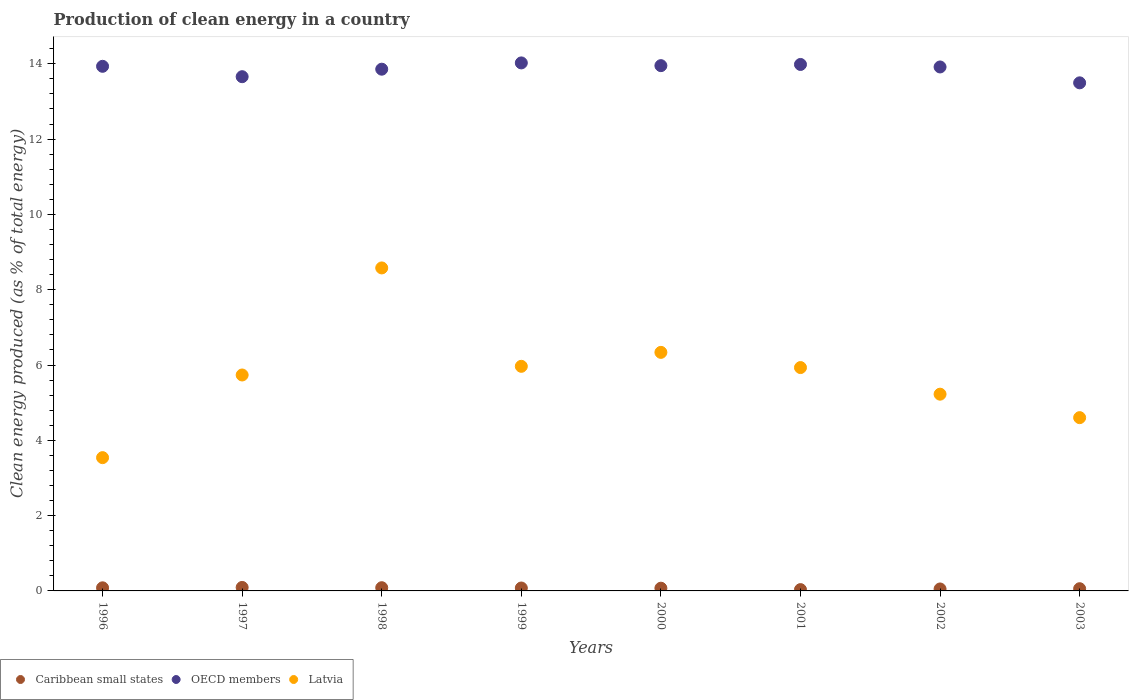Is the number of dotlines equal to the number of legend labels?
Ensure brevity in your answer.  Yes. What is the percentage of clean energy produced in Latvia in 1996?
Offer a terse response. 3.54. Across all years, what is the maximum percentage of clean energy produced in Caribbean small states?
Your answer should be very brief. 0.09. Across all years, what is the minimum percentage of clean energy produced in Latvia?
Your response must be concise. 3.54. What is the total percentage of clean energy produced in Caribbean small states in the graph?
Your answer should be compact. 0.56. What is the difference between the percentage of clean energy produced in OECD members in 2000 and that in 2003?
Ensure brevity in your answer.  0.46. What is the difference between the percentage of clean energy produced in Caribbean small states in 2000 and the percentage of clean energy produced in Latvia in 1996?
Keep it short and to the point. -3.47. What is the average percentage of clean energy produced in Latvia per year?
Make the answer very short. 5.74. In the year 1997, what is the difference between the percentage of clean energy produced in OECD members and percentage of clean energy produced in Caribbean small states?
Your answer should be very brief. 13.57. What is the ratio of the percentage of clean energy produced in OECD members in 2002 to that in 2003?
Offer a very short reply. 1.03. Is the percentage of clean energy produced in Latvia in 1997 less than that in 1998?
Give a very brief answer. Yes. What is the difference between the highest and the second highest percentage of clean energy produced in Caribbean small states?
Your answer should be very brief. 0.01. What is the difference between the highest and the lowest percentage of clean energy produced in Latvia?
Give a very brief answer. 5.04. Is the sum of the percentage of clean energy produced in OECD members in 1999 and 2001 greater than the maximum percentage of clean energy produced in Caribbean small states across all years?
Offer a terse response. Yes. Is it the case that in every year, the sum of the percentage of clean energy produced in OECD members and percentage of clean energy produced in Latvia  is greater than the percentage of clean energy produced in Caribbean small states?
Offer a terse response. Yes. Is the percentage of clean energy produced in Latvia strictly greater than the percentage of clean energy produced in OECD members over the years?
Make the answer very short. No. How many dotlines are there?
Offer a terse response. 3. Does the graph contain any zero values?
Keep it short and to the point. No. Does the graph contain grids?
Give a very brief answer. No. Where does the legend appear in the graph?
Your response must be concise. Bottom left. How many legend labels are there?
Offer a terse response. 3. How are the legend labels stacked?
Give a very brief answer. Horizontal. What is the title of the graph?
Give a very brief answer. Production of clean energy in a country. Does "Rwanda" appear as one of the legend labels in the graph?
Your answer should be very brief. No. What is the label or title of the Y-axis?
Ensure brevity in your answer.  Clean energy produced (as % of total energy). What is the Clean energy produced (as % of total energy) in Caribbean small states in 1996?
Ensure brevity in your answer.  0.08. What is the Clean energy produced (as % of total energy) of OECD members in 1996?
Your answer should be very brief. 13.93. What is the Clean energy produced (as % of total energy) in Latvia in 1996?
Provide a succinct answer. 3.54. What is the Clean energy produced (as % of total energy) of Caribbean small states in 1997?
Your answer should be very brief. 0.09. What is the Clean energy produced (as % of total energy) in OECD members in 1997?
Provide a short and direct response. 13.66. What is the Clean energy produced (as % of total energy) of Latvia in 1997?
Provide a succinct answer. 5.74. What is the Clean energy produced (as % of total energy) in Caribbean small states in 1998?
Ensure brevity in your answer.  0.09. What is the Clean energy produced (as % of total energy) of OECD members in 1998?
Your response must be concise. 13.86. What is the Clean energy produced (as % of total energy) in Latvia in 1998?
Your answer should be compact. 8.58. What is the Clean energy produced (as % of total energy) of Caribbean small states in 1999?
Make the answer very short. 0.08. What is the Clean energy produced (as % of total energy) of OECD members in 1999?
Your response must be concise. 14.02. What is the Clean energy produced (as % of total energy) of Latvia in 1999?
Ensure brevity in your answer.  5.97. What is the Clean energy produced (as % of total energy) of Caribbean small states in 2000?
Your answer should be compact. 0.07. What is the Clean energy produced (as % of total energy) of OECD members in 2000?
Provide a short and direct response. 13.95. What is the Clean energy produced (as % of total energy) in Latvia in 2000?
Make the answer very short. 6.34. What is the Clean energy produced (as % of total energy) in Caribbean small states in 2001?
Your answer should be compact. 0.03. What is the Clean energy produced (as % of total energy) in OECD members in 2001?
Offer a very short reply. 13.98. What is the Clean energy produced (as % of total energy) in Latvia in 2001?
Make the answer very short. 5.93. What is the Clean energy produced (as % of total energy) in Caribbean small states in 2002?
Provide a succinct answer. 0.05. What is the Clean energy produced (as % of total energy) in OECD members in 2002?
Offer a very short reply. 13.92. What is the Clean energy produced (as % of total energy) of Latvia in 2002?
Offer a very short reply. 5.23. What is the Clean energy produced (as % of total energy) of Caribbean small states in 2003?
Offer a terse response. 0.06. What is the Clean energy produced (as % of total energy) in OECD members in 2003?
Provide a short and direct response. 13.49. What is the Clean energy produced (as % of total energy) in Latvia in 2003?
Your response must be concise. 4.6. Across all years, what is the maximum Clean energy produced (as % of total energy) in Caribbean small states?
Your response must be concise. 0.09. Across all years, what is the maximum Clean energy produced (as % of total energy) of OECD members?
Ensure brevity in your answer.  14.02. Across all years, what is the maximum Clean energy produced (as % of total energy) of Latvia?
Your response must be concise. 8.58. Across all years, what is the minimum Clean energy produced (as % of total energy) of Caribbean small states?
Your response must be concise. 0.03. Across all years, what is the minimum Clean energy produced (as % of total energy) of OECD members?
Keep it short and to the point. 13.49. Across all years, what is the minimum Clean energy produced (as % of total energy) of Latvia?
Your answer should be very brief. 3.54. What is the total Clean energy produced (as % of total energy) in Caribbean small states in the graph?
Your answer should be very brief. 0.56. What is the total Clean energy produced (as % of total energy) in OECD members in the graph?
Your answer should be very brief. 110.82. What is the total Clean energy produced (as % of total energy) of Latvia in the graph?
Keep it short and to the point. 45.91. What is the difference between the Clean energy produced (as % of total energy) in Caribbean small states in 1996 and that in 1997?
Ensure brevity in your answer.  -0.01. What is the difference between the Clean energy produced (as % of total energy) in OECD members in 1996 and that in 1997?
Your response must be concise. 0.28. What is the difference between the Clean energy produced (as % of total energy) of Latvia in 1996 and that in 1997?
Provide a short and direct response. -2.2. What is the difference between the Clean energy produced (as % of total energy) of Caribbean small states in 1996 and that in 1998?
Make the answer very short. -0. What is the difference between the Clean energy produced (as % of total energy) of OECD members in 1996 and that in 1998?
Provide a succinct answer. 0.08. What is the difference between the Clean energy produced (as % of total energy) of Latvia in 1996 and that in 1998?
Give a very brief answer. -5.04. What is the difference between the Clean energy produced (as % of total energy) of Caribbean small states in 1996 and that in 1999?
Give a very brief answer. 0.01. What is the difference between the Clean energy produced (as % of total energy) of OECD members in 1996 and that in 1999?
Offer a terse response. -0.09. What is the difference between the Clean energy produced (as % of total energy) of Latvia in 1996 and that in 1999?
Your response must be concise. -2.43. What is the difference between the Clean energy produced (as % of total energy) of Caribbean small states in 1996 and that in 2000?
Give a very brief answer. 0.01. What is the difference between the Clean energy produced (as % of total energy) of OECD members in 1996 and that in 2000?
Ensure brevity in your answer.  -0.02. What is the difference between the Clean energy produced (as % of total energy) in Latvia in 1996 and that in 2000?
Offer a very short reply. -2.8. What is the difference between the Clean energy produced (as % of total energy) of Caribbean small states in 1996 and that in 2001?
Keep it short and to the point. 0.05. What is the difference between the Clean energy produced (as % of total energy) in OECD members in 1996 and that in 2001?
Offer a very short reply. -0.05. What is the difference between the Clean energy produced (as % of total energy) in Latvia in 1996 and that in 2001?
Ensure brevity in your answer.  -2.39. What is the difference between the Clean energy produced (as % of total energy) in Caribbean small states in 1996 and that in 2002?
Ensure brevity in your answer.  0.03. What is the difference between the Clean energy produced (as % of total energy) of OECD members in 1996 and that in 2002?
Keep it short and to the point. 0.02. What is the difference between the Clean energy produced (as % of total energy) of Latvia in 1996 and that in 2002?
Offer a terse response. -1.69. What is the difference between the Clean energy produced (as % of total energy) of Caribbean small states in 1996 and that in 2003?
Provide a short and direct response. 0.02. What is the difference between the Clean energy produced (as % of total energy) of OECD members in 1996 and that in 2003?
Provide a succinct answer. 0.44. What is the difference between the Clean energy produced (as % of total energy) of Latvia in 1996 and that in 2003?
Offer a very short reply. -1.06. What is the difference between the Clean energy produced (as % of total energy) of Caribbean small states in 1997 and that in 1998?
Give a very brief answer. 0.01. What is the difference between the Clean energy produced (as % of total energy) of OECD members in 1997 and that in 1998?
Ensure brevity in your answer.  -0.2. What is the difference between the Clean energy produced (as % of total energy) in Latvia in 1997 and that in 1998?
Your answer should be very brief. -2.84. What is the difference between the Clean energy produced (as % of total energy) in Caribbean small states in 1997 and that in 1999?
Your response must be concise. 0.02. What is the difference between the Clean energy produced (as % of total energy) in OECD members in 1997 and that in 1999?
Ensure brevity in your answer.  -0.37. What is the difference between the Clean energy produced (as % of total energy) in Latvia in 1997 and that in 1999?
Your answer should be very brief. -0.23. What is the difference between the Clean energy produced (as % of total energy) of Caribbean small states in 1997 and that in 2000?
Keep it short and to the point. 0.02. What is the difference between the Clean energy produced (as % of total energy) of OECD members in 1997 and that in 2000?
Offer a very short reply. -0.29. What is the difference between the Clean energy produced (as % of total energy) in Latvia in 1997 and that in 2000?
Your response must be concise. -0.6. What is the difference between the Clean energy produced (as % of total energy) of Caribbean small states in 1997 and that in 2001?
Your answer should be compact. 0.06. What is the difference between the Clean energy produced (as % of total energy) of OECD members in 1997 and that in 2001?
Your answer should be compact. -0.32. What is the difference between the Clean energy produced (as % of total energy) of Latvia in 1997 and that in 2001?
Provide a short and direct response. -0.2. What is the difference between the Clean energy produced (as % of total energy) in Caribbean small states in 1997 and that in 2002?
Give a very brief answer. 0.04. What is the difference between the Clean energy produced (as % of total energy) in OECD members in 1997 and that in 2002?
Your answer should be compact. -0.26. What is the difference between the Clean energy produced (as % of total energy) of Latvia in 1997 and that in 2002?
Offer a terse response. 0.51. What is the difference between the Clean energy produced (as % of total energy) of Caribbean small states in 1997 and that in 2003?
Offer a very short reply. 0.03. What is the difference between the Clean energy produced (as % of total energy) of OECD members in 1997 and that in 2003?
Provide a succinct answer. 0.16. What is the difference between the Clean energy produced (as % of total energy) in Latvia in 1997 and that in 2003?
Offer a terse response. 1.13. What is the difference between the Clean energy produced (as % of total energy) of Caribbean small states in 1998 and that in 1999?
Provide a short and direct response. 0.01. What is the difference between the Clean energy produced (as % of total energy) of OECD members in 1998 and that in 1999?
Make the answer very short. -0.17. What is the difference between the Clean energy produced (as % of total energy) of Latvia in 1998 and that in 1999?
Ensure brevity in your answer.  2.61. What is the difference between the Clean energy produced (as % of total energy) of Caribbean small states in 1998 and that in 2000?
Your response must be concise. 0.01. What is the difference between the Clean energy produced (as % of total energy) of OECD members in 1998 and that in 2000?
Keep it short and to the point. -0.09. What is the difference between the Clean energy produced (as % of total energy) in Latvia in 1998 and that in 2000?
Offer a terse response. 2.24. What is the difference between the Clean energy produced (as % of total energy) of Caribbean small states in 1998 and that in 2001?
Your answer should be compact. 0.05. What is the difference between the Clean energy produced (as % of total energy) in OECD members in 1998 and that in 2001?
Your answer should be compact. -0.13. What is the difference between the Clean energy produced (as % of total energy) of Latvia in 1998 and that in 2001?
Provide a succinct answer. 2.65. What is the difference between the Clean energy produced (as % of total energy) of Caribbean small states in 1998 and that in 2002?
Provide a succinct answer. 0.03. What is the difference between the Clean energy produced (as % of total energy) of OECD members in 1998 and that in 2002?
Your answer should be very brief. -0.06. What is the difference between the Clean energy produced (as % of total energy) of Latvia in 1998 and that in 2002?
Offer a very short reply. 3.35. What is the difference between the Clean energy produced (as % of total energy) of Caribbean small states in 1998 and that in 2003?
Your answer should be compact. 0.03. What is the difference between the Clean energy produced (as % of total energy) of OECD members in 1998 and that in 2003?
Offer a very short reply. 0.36. What is the difference between the Clean energy produced (as % of total energy) in Latvia in 1998 and that in 2003?
Give a very brief answer. 3.98. What is the difference between the Clean energy produced (as % of total energy) of Caribbean small states in 1999 and that in 2000?
Your answer should be very brief. 0.01. What is the difference between the Clean energy produced (as % of total energy) in OECD members in 1999 and that in 2000?
Provide a short and direct response. 0.07. What is the difference between the Clean energy produced (as % of total energy) in Latvia in 1999 and that in 2000?
Make the answer very short. -0.37. What is the difference between the Clean energy produced (as % of total energy) in Caribbean small states in 1999 and that in 2001?
Keep it short and to the point. 0.04. What is the difference between the Clean energy produced (as % of total energy) of OECD members in 1999 and that in 2001?
Your answer should be compact. 0.04. What is the difference between the Clean energy produced (as % of total energy) of Latvia in 1999 and that in 2001?
Your response must be concise. 0.03. What is the difference between the Clean energy produced (as % of total energy) of Caribbean small states in 1999 and that in 2002?
Make the answer very short. 0.03. What is the difference between the Clean energy produced (as % of total energy) of OECD members in 1999 and that in 2002?
Your answer should be very brief. 0.11. What is the difference between the Clean energy produced (as % of total energy) in Latvia in 1999 and that in 2002?
Give a very brief answer. 0.74. What is the difference between the Clean energy produced (as % of total energy) in Caribbean small states in 1999 and that in 2003?
Give a very brief answer. 0.02. What is the difference between the Clean energy produced (as % of total energy) in OECD members in 1999 and that in 2003?
Provide a succinct answer. 0.53. What is the difference between the Clean energy produced (as % of total energy) in Latvia in 1999 and that in 2003?
Offer a terse response. 1.36. What is the difference between the Clean energy produced (as % of total energy) of Caribbean small states in 2000 and that in 2001?
Give a very brief answer. 0.04. What is the difference between the Clean energy produced (as % of total energy) in OECD members in 2000 and that in 2001?
Offer a very short reply. -0.03. What is the difference between the Clean energy produced (as % of total energy) of Latvia in 2000 and that in 2001?
Offer a terse response. 0.4. What is the difference between the Clean energy produced (as % of total energy) of Caribbean small states in 2000 and that in 2002?
Make the answer very short. 0.02. What is the difference between the Clean energy produced (as % of total energy) of OECD members in 2000 and that in 2002?
Make the answer very short. 0.04. What is the difference between the Clean energy produced (as % of total energy) of Latvia in 2000 and that in 2002?
Your response must be concise. 1.11. What is the difference between the Clean energy produced (as % of total energy) of Caribbean small states in 2000 and that in 2003?
Your response must be concise. 0.01. What is the difference between the Clean energy produced (as % of total energy) in OECD members in 2000 and that in 2003?
Offer a terse response. 0.46. What is the difference between the Clean energy produced (as % of total energy) of Latvia in 2000 and that in 2003?
Provide a short and direct response. 1.73. What is the difference between the Clean energy produced (as % of total energy) in Caribbean small states in 2001 and that in 2002?
Offer a very short reply. -0.02. What is the difference between the Clean energy produced (as % of total energy) in OECD members in 2001 and that in 2002?
Give a very brief answer. 0.07. What is the difference between the Clean energy produced (as % of total energy) of Latvia in 2001 and that in 2002?
Your response must be concise. 0.71. What is the difference between the Clean energy produced (as % of total energy) in Caribbean small states in 2001 and that in 2003?
Your answer should be compact. -0.02. What is the difference between the Clean energy produced (as % of total energy) in OECD members in 2001 and that in 2003?
Your answer should be compact. 0.49. What is the difference between the Clean energy produced (as % of total energy) of Latvia in 2001 and that in 2003?
Offer a terse response. 1.33. What is the difference between the Clean energy produced (as % of total energy) of Caribbean small states in 2002 and that in 2003?
Keep it short and to the point. -0.01. What is the difference between the Clean energy produced (as % of total energy) of OECD members in 2002 and that in 2003?
Offer a terse response. 0.42. What is the difference between the Clean energy produced (as % of total energy) in Latvia in 2002 and that in 2003?
Your answer should be compact. 0.62. What is the difference between the Clean energy produced (as % of total energy) of Caribbean small states in 1996 and the Clean energy produced (as % of total energy) of OECD members in 1997?
Your answer should be compact. -13.58. What is the difference between the Clean energy produced (as % of total energy) of Caribbean small states in 1996 and the Clean energy produced (as % of total energy) of Latvia in 1997?
Your response must be concise. -5.65. What is the difference between the Clean energy produced (as % of total energy) of OECD members in 1996 and the Clean energy produced (as % of total energy) of Latvia in 1997?
Provide a short and direct response. 8.2. What is the difference between the Clean energy produced (as % of total energy) in Caribbean small states in 1996 and the Clean energy produced (as % of total energy) in OECD members in 1998?
Provide a succinct answer. -13.77. What is the difference between the Clean energy produced (as % of total energy) in Caribbean small states in 1996 and the Clean energy produced (as % of total energy) in Latvia in 1998?
Make the answer very short. -8.5. What is the difference between the Clean energy produced (as % of total energy) of OECD members in 1996 and the Clean energy produced (as % of total energy) of Latvia in 1998?
Your answer should be compact. 5.36. What is the difference between the Clean energy produced (as % of total energy) of Caribbean small states in 1996 and the Clean energy produced (as % of total energy) of OECD members in 1999?
Offer a terse response. -13.94. What is the difference between the Clean energy produced (as % of total energy) of Caribbean small states in 1996 and the Clean energy produced (as % of total energy) of Latvia in 1999?
Provide a succinct answer. -5.88. What is the difference between the Clean energy produced (as % of total energy) in OECD members in 1996 and the Clean energy produced (as % of total energy) in Latvia in 1999?
Provide a succinct answer. 7.97. What is the difference between the Clean energy produced (as % of total energy) in Caribbean small states in 1996 and the Clean energy produced (as % of total energy) in OECD members in 2000?
Your answer should be very brief. -13.87. What is the difference between the Clean energy produced (as % of total energy) in Caribbean small states in 1996 and the Clean energy produced (as % of total energy) in Latvia in 2000?
Keep it short and to the point. -6.25. What is the difference between the Clean energy produced (as % of total energy) in OECD members in 1996 and the Clean energy produced (as % of total energy) in Latvia in 2000?
Ensure brevity in your answer.  7.6. What is the difference between the Clean energy produced (as % of total energy) of Caribbean small states in 1996 and the Clean energy produced (as % of total energy) of OECD members in 2001?
Ensure brevity in your answer.  -13.9. What is the difference between the Clean energy produced (as % of total energy) in Caribbean small states in 1996 and the Clean energy produced (as % of total energy) in Latvia in 2001?
Make the answer very short. -5.85. What is the difference between the Clean energy produced (as % of total energy) in OECD members in 1996 and the Clean energy produced (as % of total energy) in Latvia in 2001?
Ensure brevity in your answer.  8. What is the difference between the Clean energy produced (as % of total energy) in Caribbean small states in 1996 and the Clean energy produced (as % of total energy) in OECD members in 2002?
Your response must be concise. -13.83. What is the difference between the Clean energy produced (as % of total energy) in Caribbean small states in 1996 and the Clean energy produced (as % of total energy) in Latvia in 2002?
Ensure brevity in your answer.  -5.14. What is the difference between the Clean energy produced (as % of total energy) in OECD members in 1996 and the Clean energy produced (as % of total energy) in Latvia in 2002?
Make the answer very short. 8.71. What is the difference between the Clean energy produced (as % of total energy) of Caribbean small states in 1996 and the Clean energy produced (as % of total energy) of OECD members in 2003?
Make the answer very short. -13.41. What is the difference between the Clean energy produced (as % of total energy) in Caribbean small states in 1996 and the Clean energy produced (as % of total energy) in Latvia in 2003?
Your response must be concise. -4.52. What is the difference between the Clean energy produced (as % of total energy) in OECD members in 1996 and the Clean energy produced (as % of total energy) in Latvia in 2003?
Make the answer very short. 9.33. What is the difference between the Clean energy produced (as % of total energy) in Caribbean small states in 1997 and the Clean energy produced (as % of total energy) in OECD members in 1998?
Ensure brevity in your answer.  -13.76. What is the difference between the Clean energy produced (as % of total energy) in Caribbean small states in 1997 and the Clean energy produced (as % of total energy) in Latvia in 1998?
Ensure brevity in your answer.  -8.49. What is the difference between the Clean energy produced (as % of total energy) in OECD members in 1997 and the Clean energy produced (as % of total energy) in Latvia in 1998?
Your answer should be very brief. 5.08. What is the difference between the Clean energy produced (as % of total energy) in Caribbean small states in 1997 and the Clean energy produced (as % of total energy) in OECD members in 1999?
Provide a short and direct response. -13.93. What is the difference between the Clean energy produced (as % of total energy) in Caribbean small states in 1997 and the Clean energy produced (as % of total energy) in Latvia in 1999?
Offer a very short reply. -5.87. What is the difference between the Clean energy produced (as % of total energy) of OECD members in 1997 and the Clean energy produced (as % of total energy) of Latvia in 1999?
Keep it short and to the point. 7.69. What is the difference between the Clean energy produced (as % of total energy) in Caribbean small states in 1997 and the Clean energy produced (as % of total energy) in OECD members in 2000?
Keep it short and to the point. -13.86. What is the difference between the Clean energy produced (as % of total energy) in Caribbean small states in 1997 and the Clean energy produced (as % of total energy) in Latvia in 2000?
Provide a succinct answer. -6.24. What is the difference between the Clean energy produced (as % of total energy) in OECD members in 1997 and the Clean energy produced (as % of total energy) in Latvia in 2000?
Ensure brevity in your answer.  7.32. What is the difference between the Clean energy produced (as % of total energy) in Caribbean small states in 1997 and the Clean energy produced (as % of total energy) in OECD members in 2001?
Make the answer very short. -13.89. What is the difference between the Clean energy produced (as % of total energy) of Caribbean small states in 1997 and the Clean energy produced (as % of total energy) of Latvia in 2001?
Keep it short and to the point. -5.84. What is the difference between the Clean energy produced (as % of total energy) of OECD members in 1997 and the Clean energy produced (as % of total energy) of Latvia in 2001?
Make the answer very short. 7.73. What is the difference between the Clean energy produced (as % of total energy) in Caribbean small states in 1997 and the Clean energy produced (as % of total energy) in OECD members in 2002?
Your answer should be compact. -13.82. What is the difference between the Clean energy produced (as % of total energy) in Caribbean small states in 1997 and the Clean energy produced (as % of total energy) in Latvia in 2002?
Your answer should be very brief. -5.13. What is the difference between the Clean energy produced (as % of total energy) of OECD members in 1997 and the Clean energy produced (as % of total energy) of Latvia in 2002?
Ensure brevity in your answer.  8.43. What is the difference between the Clean energy produced (as % of total energy) of Caribbean small states in 1997 and the Clean energy produced (as % of total energy) of OECD members in 2003?
Provide a succinct answer. -13.4. What is the difference between the Clean energy produced (as % of total energy) in Caribbean small states in 1997 and the Clean energy produced (as % of total energy) in Latvia in 2003?
Keep it short and to the point. -4.51. What is the difference between the Clean energy produced (as % of total energy) in OECD members in 1997 and the Clean energy produced (as % of total energy) in Latvia in 2003?
Keep it short and to the point. 9.06. What is the difference between the Clean energy produced (as % of total energy) in Caribbean small states in 1998 and the Clean energy produced (as % of total energy) in OECD members in 1999?
Ensure brevity in your answer.  -13.94. What is the difference between the Clean energy produced (as % of total energy) in Caribbean small states in 1998 and the Clean energy produced (as % of total energy) in Latvia in 1999?
Ensure brevity in your answer.  -5.88. What is the difference between the Clean energy produced (as % of total energy) of OECD members in 1998 and the Clean energy produced (as % of total energy) of Latvia in 1999?
Your answer should be compact. 7.89. What is the difference between the Clean energy produced (as % of total energy) of Caribbean small states in 1998 and the Clean energy produced (as % of total energy) of OECD members in 2000?
Give a very brief answer. -13.87. What is the difference between the Clean energy produced (as % of total energy) in Caribbean small states in 1998 and the Clean energy produced (as % of total energy) in Latvia in 2000?
Offer a terse response. -6.25. What is the difference between the Clean energy produced (as % of total energy) of OECD members in 1998 and the Clean energy produced (as % of total energy) of Latvia in 2000?
Keep it short and to the point. 7.52. What is the difference between the Clean energy produced (as % of total energy) in Caribbean small states in 1998 and the Clean energy produced (as % of total energy) in OECD members in 2001?
Keep it short and to the point. -13.9. What is the difference between the Clean energy produced (as % of total energy) in Caribbean small states in 1998 and the Clean energy produced (as % of total energy) in Latvia in 2001?
Provide a succinct answer. -5.85. What is the difference between the Clean energy produced (as % of total energy) in OECD members in 1998 and the Clean energy produced (as % of total energy) in Latvia in 2001?
Make the answer very short. 7.92. What is the difference between the Clean energy produced (as % of total energy) of Caribbean small states in 1998 and the Clean energy produced (as % of total energy) of OECD members in 2002?
Ensure brevity in your answer.  -13.83. What is the difference between the Clean energy produced (as % of total energy) in Caribbean small states in 1998 and the Clean energy produced (as % of total energy) in Latvia in 2002?
Keep it short and to the point. -5.14. What is the difference between the Clean energy produced (as % of total energy) of OECD members in 1998 and the Clean energy produced (as % of total energy) of Latvia in 2002?
Ensure brevity in your answer.  8.63. What is the difference between the Clean energy produced (as % of total energy) of Caribbean small states in 1998 and the Clean energy produced (as % of total energy) of OECD members in 2003?
Your answer should be very brief. -13.41. What is the difference between the Clean energy produced (as % of total energy) in Caribbean small states in 1998 and the Clean energy produced (as % of total energy) in Latvia in 2003?
Offer a very short reply. -4.52. What is the difference between the Clean energy produced (as % of total energy) in OECD members in 1998 and the Clean energy produced (as % of total energy) in Latvia in 2003?
Provide a short and direct response. 9.25. What is the difference between the Clean energy produced (as % of total energy) of Caribbean small states in 1999 and the Clean energy produced (as % of total energy) of OECD members in 2000?
Your answer should be very brief. -13.87. What is the difference between the Clean energy produced (as % of total energy) in Caribbean small states in 1999 and the Clean energy produced (as % of total energy) in Latvia in 2000?
Your response must be concise. -6.26. What is the difference between the Clean energy produced (as % of total energy) of OECD members in 1999 and the Clean energy produced (as % of total energy) of Latvia in 2000?
Provide a succinct answer. 7.69. What is the difference between the Clean energy produced (as % of total energy) in Caribbean small states in 1999 and the Clean energy produced (as % of total energy) in OECD members in 2001?
Give a very brief answer. -13.91. What is the difference between the Clean energy produced (as % of total energy) of Caribbean small states in 1999 and the Clean energy produced (as % of total energy) of Latvia in 2001?
Offer a terse response. -5.85. What is the difference between the Clean energy produced (as % of total energy) in OECD members in 1999 and the Clean energy produced (as % of total energy) in Latvia in 2001?
Your answer should be compact. 8.09. What is the difference between the Clean energy produced (as % of total energy) of Caribbean small states in 1999 and the Clean energy produced (as % of total energy) of OECD members in 2002?
Provide a short and direct response. -13.84. What is the difference between the Clean energy produced (as % of total energy) of Caribbean small states in 1999 and the Clean energy produced (as % of total energy) of Latvia in 2002?
Your response must be concise. -5.15. What is the difference between the Clean energy produced (as % of total energy) in OECD members in 1999 and the Clean energy produced (as % of total energy) in Latvia in 2002?
Your answer should be very brief. 8.8. What is the difference between the Clean energy produced (as % of total energy) in Caribbean small states in 1999 and the Clean energy produced (as % of total energy) in OECD members in 2003?
Make the answer very short. -13.42. What is the difference between the Clean energy produced (as % of total energy) in Caribbean small states in 1999 and the Clean energy produced (as % of total energy) in Latvia in 2003?
Your response must be concise. -4.52. What is the difference between the Clean energy produced (as % of total energy) in OECD members in 1999 and the Clean energy produced (as % of total energy) in Latvia in 2003?
Your response must be concise. 9.42. What is the difference between the Clean energy produced (as % of total energy) in Caribbean small states in 2000 and the Clean energy produced (as % of total energy) in OECD members in 2001?
Give a very brief answer. -13.91. What is the difference between the Clean energy produced (as % of total energy) in Caribbean small states in 2000 and the Clean energy produced (as % of total energy) in Latvia in 2001?
Your answer should be compact. -5.86. What is the difference between the Clean energy produced (as % of total energy) of OECD members in 2000 and the Clean energy produced (as % of total energy) of Latvia in 2001?
Your response must be concise. 8.02. What is the difference between the Clean energy produced (as % of total energy) of Caribbean small states in 2000 and the Clean energy produced (as % of total energy) of OECD members in 2002?
Give a very brief answer. -13.84. What is the difference between the Clean energy produced (as % of total energy) in Caribbean small states in 2000 and the Clean energy produced (as % of total energy) in Latvia in 2002?
Provide a short and direct response. -5.15. What is the difference between the Clean energy produced (as % of total energy) of OECD members in 2000 and the Clean energy produced (as % of total energy) of Latvia in 2002?
Provide a short and direct response. 8.73. What is the difference between the Clean energy produced (as % of total energy) of Caribbean small states in 2000 and the Clean energy produced (as % of total energy) of OECD members in 2003?
Your response must be concise. -13.42. What is the difference between the Clean energy produced (as % of total energy) in Caribbean small states in 2000 and the Clean energy produced (as % of total energy) in Latvia in 2003?
Give a very brief answer. -4.53. What is the difference between the Clean energy produced (as % of total energy) of OECD members in 2000 and the Clean energy produced (as % of total energy) of Latvia in 2003?
Ensure brevity in your answer.  9.35. What is the difference between the Clean energy produced (as % of total energy) of Caribbean small states in 2001 and the Clean energy produced (as % of total energy) of OECD members in 2002?
Your answer should be very brief. -13.88. What is the difference between the Clean energy produced (as % of total energy) of Caribbean small states in 2001 and the Clean energy produced (as % of total energy) of Latvia in 2002?
Make the answer very short. -5.19. What is the difference between the Clean energy produced (as % of total energy) in OECD members in 2001 and the Clean energy produced (as % of total energy) in Latvia in 2002?
Ensure brevity in your answer.  8.76. What is the difference between the Clean energy produced (as % of total energy) in Caribbean small states in 2001 and the Clean energy produced (as % of total energy) in OECD members in 2003?
Your answer should be compact. -13.46. What is the difference between the Clean energy produced (as % of total energy) in Caribbean small states in 2001 and the Clean energy produced (as % of total energy) in Latvia in 2003?
Ensure brevity in your answer.  -4.57. What is the difference between the Clean energy produced (as % of total energy) in OECD members in 2001 and the Clean energy produced (as % of total energy) in Latvia in 2003?
Offer a very short reply. 9.38. What is the difference between the Clean energy produced (as % of total energy) in Caribbean small states in 2002 and the Clean energy produced (as % of total energy) in OECD members in 2003?
Make the answer very short. -13.44. What is the difference between the Clean energy produced (as % of total energy) of Caribbean small states in 2002 and the Clean energy produced (as % of total energy) of Latvia in 2003?
Your response must be concise. -4.55. What is the difference between the Clean energy produced (as % of total energy) of OECD members in 2002 and the Clean energy produced (as % of total energy) of Latvia in 2003?
Your answer should be very brief. 9.31. What is the average Clean energy produced (as % of total energy) of Caribbean small states per year?
Ensure brevity in your answer.  0.07. What is the average Clean energy produced (as % of total energy) of OECD members per year?
Make the answer very short. 13.85. What is the average Clean energy produced (as % of total energy) of Latvia per year?
Ensure brevity in your answer.  5.74. In the year 1996, what is the difference between the Clean energy produced (as % of total energy) in Caribbean small states and Clean energy produced (as % of total energy) in OECD members?
Offer a very short reply. -13.85. In the year 1996, what is the difference between the Clean energy produced (as % of total energy) in Caribbean small states and Clean energy produced (as % of total energy) in Latvia?
Give a very brief answer. -3.46. In the year 1996, what is the difference between the Clean energy produced (as % of total energy) of OECD members and Clean energy produced (as % of total energy) of Latvia?
Provide a succinct answer. 10.39. In the year 1997, what is the difference between the Clean energy produced (as % of total energy) in Caribbean small states and Clean energy produced (as % of total energy) in OECD members?
Offer a terse response. -13.57. In the year 1997, what is the difference between the Clean energy produced (as % of total energy) in Caribbean small states and Clean energy produced (as % of total energy) in Latvia?
Provide a short and direct response. -5.64. In the year 1997, what is the difference between the Clean energy produced (as % of total energy) of OECD members and Clean energy produced (as % of total energy) of Latvia?
Keep it short and to the point. 7.92. In the year 1998, what is the difference between the Clean energy produced (as % of total energy) of Caribbean small states and Clean energy produced (as % of total energy) of OECD members?
Your response must be concise. -13.77. In the year 1998, what is the difference between the Clean energy produced (as % of total energy) in Caribbean small states and Clean energy produced (as % of total energy) in Latvia?
Provide a succinct answer. -8.49. In the year 1998, what is the difference between the Clean energy produced (as % of total energy) of OECD members and Clean energy produced (as % of total energy) of Latvia?
Your answer should be compact. 5.28. In the year 1999, what is the difference between the Clean energy produced (as % of total energy) of Caribbean small states and Clean energy produced (as % of total energy) of OECD members?
Make the answer very short. -13.95. In the year 1999, what is the difference between the Clean energy produced (as % of total energy) in Caribbean small states and Clean energy produced (as % of total energy) in Latvia?
Make the answer very short. -5.89. In the year 1999, what is the difference between the Clean energy produced (as % of total energy) of OECD members and Clean energy produced (as % of total energy) of Latvia?
Provide a short and direct response. 8.06. In the year 2000, what is the difference between the Clean energy produced (as % of total energy) of Caribbean small states and Clean energy produced (as % of total energy) of OECD members?
Give a very brief answer. -13.88. In the year 2000, what is the difference between the Clean energy produced (as % of total energy) in Caribbean small states and Clean energy produced (as % of total energy) in Latvia?
Your response must be concise. -6.26. In the year 2000, what is the difference between the Clean energy produced (as % of total energy) in OECD members and Clean energy produced (as % of total energy) in Latvia?
Provide a short and direct response. 7.62. In the year 2001, what is the difference between the Clean energy produced (as % of total energy) in Caribbean small states and Clean energy produced (as % of total energy) in OECD members?
Give a very brief answer. -13.95. In the year 2001, what is the difference between the Clean energy produced (as % of total energy) of Caribbean small states and Clean energy produced (as % of total energy) of Latvia?
Offer a very short reply. -5.9. In the year 2001, what is the difference between the Clean energy produced (as % of total energy) of OECD members and Clean energy produced (as % of total energy) of Latvia?
Provide a short and direct response. 8.05. In the year 2002, what is the difference between the Clean energy produced (as % of total energy) in Caribbean small states and Clean energy produced (as % of total energy) in OECD members?
Provide a short and direct response. -13.86. In the year 2002, what is the difference between the Clean energy produced (as % of total energy) in Caribbean small states and Clean energy produced (as % of total energy) in Latvia?
Offer a very short reply. -5.17. In the year 2002, what is the difference between the Clean energy produced (as % of total energy) of OECD members and Clean energy produced (as % of total energy) of Latvia?
Your answer should be very brief. 8.69. In the year 2003, what is the difference between the Clean energy produced (as % of total energy) of Caribbean small states and Clean energy produced (as % of total energy) of OECD members?
Make the answer very short. -13.44. In the year 2003, what is the difference between the Clean energy produced (as % of total energy) of Caribbean small states and Clean energy produced (as % of total energy) of Latvia?
Your response must be concise. -4.54. In the year 2003, what is the difference between the Clean energy produced (as % of total energy) of OECD members and Clean energy produced (as % of total energy) of Latvia?
Your answer should be compact. 8.89. What is the ratio of the Clean energy produced (as % of total energy) in Caribbean small states in 1996 to that in 1997?
Ensure brevity in your answer.  0.89. What is the ratio of the Clean energy produced (as % of total energy) of OECD members in 1996 to that in 1997?
Your answer should be very brief. 1.02. What is the ratio of the Clean energy produced (as % of total energy) of Latvia in 1996 to that in 1997?
Ensure brevity in your answer.  0.62. What is the ratio of the Clean energy produced (as % of total energy) of Caribbean small states in 1996 to that in 1998?
Your answer should be compact. 0.96. What is the ratio of the Clean energy produced (as % of total energy) of Latvia in 1996 to that in 1998?
Ensure brevity in your answer.  0.41. What is the ratio of the Clean energy produced (as % of total energy) in Caribbean small states in 1996 to that in 1999?
Make the answer very short. 1.07. What is the ratio of the Clean energy produced (as % of total energy) in OECD members in 1996 to that in 1999?
Offer a terse response. 0.99. What is the ratio of the Clean energy produced (as % of total energy) of Latvia in 1996 to that in 1999?
Give a very brief answer. 0.59. What is the ratio of the Clean energy produced (as % of total energy) of Caribbean small states in 1996 to that in 2000?
Your answer should be compact. 1.14. What is the ratio of the Clean energy produced (as % of total energy) in Latvia in 1996 to that in 2000?
Provide a succinct answer. 0.56. What is the ratio of the Clean energy produced (as % of total energy) of Caribbean small states in 1996 to that in 2001?
Provide a short and direct response. 2.37. What is the ratio of the Clean energy produced (as % of total energy) of OECD members in 1996 to that in 2001?
Provide a short and direct response. 1. What is the ratio of the Clean energy produced (as % of total energy) in Latvia in 1996 to that in 2001?
Give a very brief answer. 0.6. What is the ratio of the Clean energy produced (as % of total energy) of Caribbean small states in 1996 to that in 2002?
Provide a short and direct response. 1.58. What is the ratio of the Clean energy produced (as % of total energy) in Latvia in 1996 to that in 2002?
Give a very brief answer. 0.68. What is the ratio of the Clean energy produced (as % of total energy) of Caribbean small states in 1996 to that in 2003?
Keep it short and to the point. 1.4. What is the ratio of the Clean energy produced (as % of total energy) in OECD members in 1996 to that in 2003?
Offer a very short reply. 1.03. What is the ratio of the Clean energy produced (as % of total energy) of Latvia in 1996 to that in 2003?
Offer a very short reply. 0.77. What is the ratio of the Clean energy produced (as % of total energy) in Caribbean small states in 1997 to that in 1998?
Your response must be concise. 1.08. What is the ratio of the Clean energy produced (as % of total energy) in OECD members in 1997 to that in 1998?
Ensure brevity in your answer.  0.99. What is the ratio of the Clean energy produced (as % of total energy) of Latvia in 1997 to that in 1998?
Keep it short and to the point. 0.67. What is the ratio of the Clean energy produced (as % of total energy) in Caribbean small states in 1997 to that in 1999?
Your answer should be very brief. 1.2. What is the ratio of the Clean energy produced (as % of total energy) of OECD members in 1997 to that in 1999?
Make the answer very short. 0.97. What is the ratio of the Clean energy produced (as % of total energy) in Latvia in 1997 to that in 1999?
Give a very brief answer. 0.96. What is the ratio of the Clean energy produced (as % of total energy) of Caribbean small states in 1997 to that in 2000?
Your answer should be very brief. 1.28. What is the ratio of the Clean energy produced (as % of total energy) in OECD members in 1997 to that in 2000?
Provide a short and direct response. 0.98. What is the ratio of the Clean energy produced (as % of total energy) of Latvia in 1997 to that in 2000?
Offer a terse response. 0.91. What is the ratio of the Clean energy produced (as % of total energy) in Caribbean small states in 1997 to that in 2001?
Offer a very short reply. 2.66. What is the ratio of the Clean energy produced (as % of total energy) of OECD members in 1997 to that in 2001?
Keep it short and to the point. 0.98. What is the ratio of the Clean energy produced (as % of total energy) in Latvia in 1997 to that in 2001?
Your answer should be compact. 0.97. What is the ratio of the Clean energy produced (as % of total energy) in Caribbean small states in 1997 to that in 2002?
Your response must be concise. 1.78. What is the ratio of the Clean energy produced (as % of total energy) of OECD members in 1997 to that in 2002?
Your response must be concise. 0.98. What is the ratio of the Clean energy produced (as % of total energy) of Latvia in 1997 to that in 2002?
Keep it short and to the point. 1.1. What is the ratio of the Clean energy produced (as % of total energy) of Caribbean small states in 1997 to that in 2003?
Your answer should be compact. 1.57. What is the ratio of the Clean energy produced (as % of total energy) of OECD members in 1997 to that in 2003?
Offer a terse response. 1.01. What is the ratio of the Clean energy produced (as % of total energy) of Latvia in 1997 to that in 2003?
Make the answer very short. 1.25. What is the ratio of the Clean energy produced (as % of total energy) of Caribbean small states in 1998 to that in 1999?
Provide a succinct answer. 1.11. What is the ratio of the Clean energy produced (as % of total energy) in OECD members in 1998 to that in 1999?
Ensure brevity in your answer.  0.99. What is the ratio of the Clean energy produced (as % of total energy) of Latvia in 1998 to that in 1999?
Keep it short and to the point. 1.44. What is the ratio of the Clean energy produced (as % of total energy) in Caribbean small states in 1998 to that in 2000?
Keep it short and to the point. 1.18. What is the ratio of the Clean energy produced (as % of total energy) in Latvia in 1998 to that in 2000?
Make the answer very short. 1.35. What is the ratio of the Clean energy produced (as % of total energy) of Caribbean small states in 1998 to that in 2001?
Give a very brief answer. 2.46. What is the ratio of the Clean energy produced (as % of total energy) of OECD members in 1998 to that in 2001?
Ensure brevity in your answer.  0.99. What is the ratio of the Clean energy produced (as % of total energy) in Latvia in 1998 to that in 2001?
Make the answer very short. 1.45. What is the ratio of the Clean energy produced (as % of total energy) of Caribbean small states in 1998 to that in 2002?
Offer a very short reply. 1.64. What is the ratio of the Clean energy produced (as % of total energy) in Latvia in 1998 to that in 2002?
Offer a terse response. 1.64. What is the ratio of the Clean energy produced (as % of total energy) in Caribbean small states in 1998 to that in 2003?
Provide a short and direct response. 1.45. What is the ratio of the Clean energy produced (as % of total energy) in OECD members in 1998 to that in 2003?
Ensure brevity in your answer.  1.03. What is the ratio of the Clean energy produced (as % of total energy) in Latvia in 1998 to that in 2003?
Provide a short and direct response. 1.86. What is the ratio of the Clean energy produced (as % of total energy) in Caribbean small states in 1999 to that in 2000?
Keep it short and to the point. 1.07. What is the ratio of the Clean energy produced (as % of total energy) of OECD members in 1999 to that in 2000?
Provide a short and direct response. 1.01. What is the ratio of the Clean energy produced (as % of total energy) in Latvia in 1999 to that in 2000?
Give a very brief answer. 0.94. What is the ratio of the Clean energy produced (as % of total energy) of Caribbean small states in 1999 to that in 2001?
Make the answer very short. 2.22. What is the ratio of the Clean energy produced (as % of total energy) of Latvia in 1999 to that in 2001?
Make the answer very short. 1.01. What is the ratio of the Clean energy produced (as % of total energy) of Caribbean small states in 1999 to that in 2002?
Your answer should be compact. 1.49. What is the ratio of the Clean energy produced (as % of total energy) of OECD members in 1999 to that in 2002?
Your response must be concise. 1.01. What is the ratio of the Clean energy produced (as % of total energy) in Latvia in 1999 to that in 2002?
Your answer should be very brief. 1.14. What is the ratio of the Clean energy produced (as % of total energy) of Caribbean small states in 1999 to that in 2003?
Provide a short and direct response. 1.31. What is the ratio of the Clean energy produced (as % of total energy) of OECD members in 1999 to that in 2003?
Ensure brevity in your answer.  1.04. What is the ratio of the Clean energy produced (as % of total energy) in Latvia in 1999 to that in 2003?
Your answer should be very brief. 1.3. What is the ratio of the Clean energy produced (as % of total energy) in Caribbean small states in 2000 to that in 2001?
Make the answer very short. 2.08. What is the ratio of the Clean energy produced (as % of total energy) of Latvia in 2000 to that in 2001?
Give a very brief answer. 1.07. What is the ratio of the Clean energy produced (as % of total energy) of Caribbean small states in 2000 to that in 2002?
Your response must be concise. 1.39. What is the ratio of the Clean energy produced (as % of total energy) in Latvia in 2000 to that in 2002?
Give a very brief answer. 1.21. What is the ratio of the Clean energy produced (as % of total energy) in Caribbean small states in 2000 to that in 2003?
Make the answer very short. 1.23. What is the ratio of the Clean energy produced (as % of total energy) in OECD members in 2000 to that in 2003?
Provide a short and direct response. 1.03. What is the ratio of the Clean energy produced (as % of total energy) of Latvia in 2000 to that in 2003?
Your answer should be compact. 1.38. What is the ratio of the Clean energy produced (as % of total energy) of Caribbean small states in 2001 to that in 2002?
Your response must be concise. 0.67. What is the ratio of the Clean energy produced (as % of total energy) in OECD members in 2001 to that in 2002?
Your answer should be compact. 1. What is the ratio of the Clean energy produced (as % of total energy) in Latvia in 2001 to that in 2002?
Give a very brief answer. 1.14. What is the ratio of the Clean energy produced (as % of total energy) of Caribbean small states in 2001 to that in 2003?
Keep it short and to the point. 0.59. What is the ratio of the Clean energy produced (as % of total energy) of OECD members in 2001 to that in 2003?
Provide a succinct answer. 1.04. What is the ratio of the Clean energy produced (as % of total energy) of Latvia in 2001 to that in 2003?
Keep it short and to the point. 1.29. What is the ratio of the Clean energy produced (as % of total energy) of Caribbean small states in 2002 to that in 2003?
Your answer should be very brief. 0.88. What is the ratio of the Clean energy produced (as % of total energy) of OECD members in 2002 to that in 2003?
Make the answer very short. 1.03. What is the ratio of the Clean energy produced (as % of total energy) in Latvia in 2002 to that in 2003?
Your answer should be compact. 1.14. What is the difference between the highest and the second highest Clean energy produced (as % of total energy) of Caribbean small states?
Your answer should be very brief. 0.01. What is the difference between the highest and the second highest Clean energy produced (as % of total energy) of OECD members?
Give a very brief answer. 0.04. What is the difference between the highest and the second highest Clean energy produced (as % of total energy) in Latvia?
Give a very brief answer. 2.24. What is the difference between the highest and the lowest Clean energy produced (as % of total energy) in Caribbean small states?
Your answer should be compact. 0.06. What is the difference between the highest and the lowest Clean energy produced (as % of total energy) of OECD members?
Provide a succinct answer. 0.53. What is the difference between the highest and the lowest Clean energy produced (as % of total energy) in Latvia?
Keep it short and to the point. 5.04. 